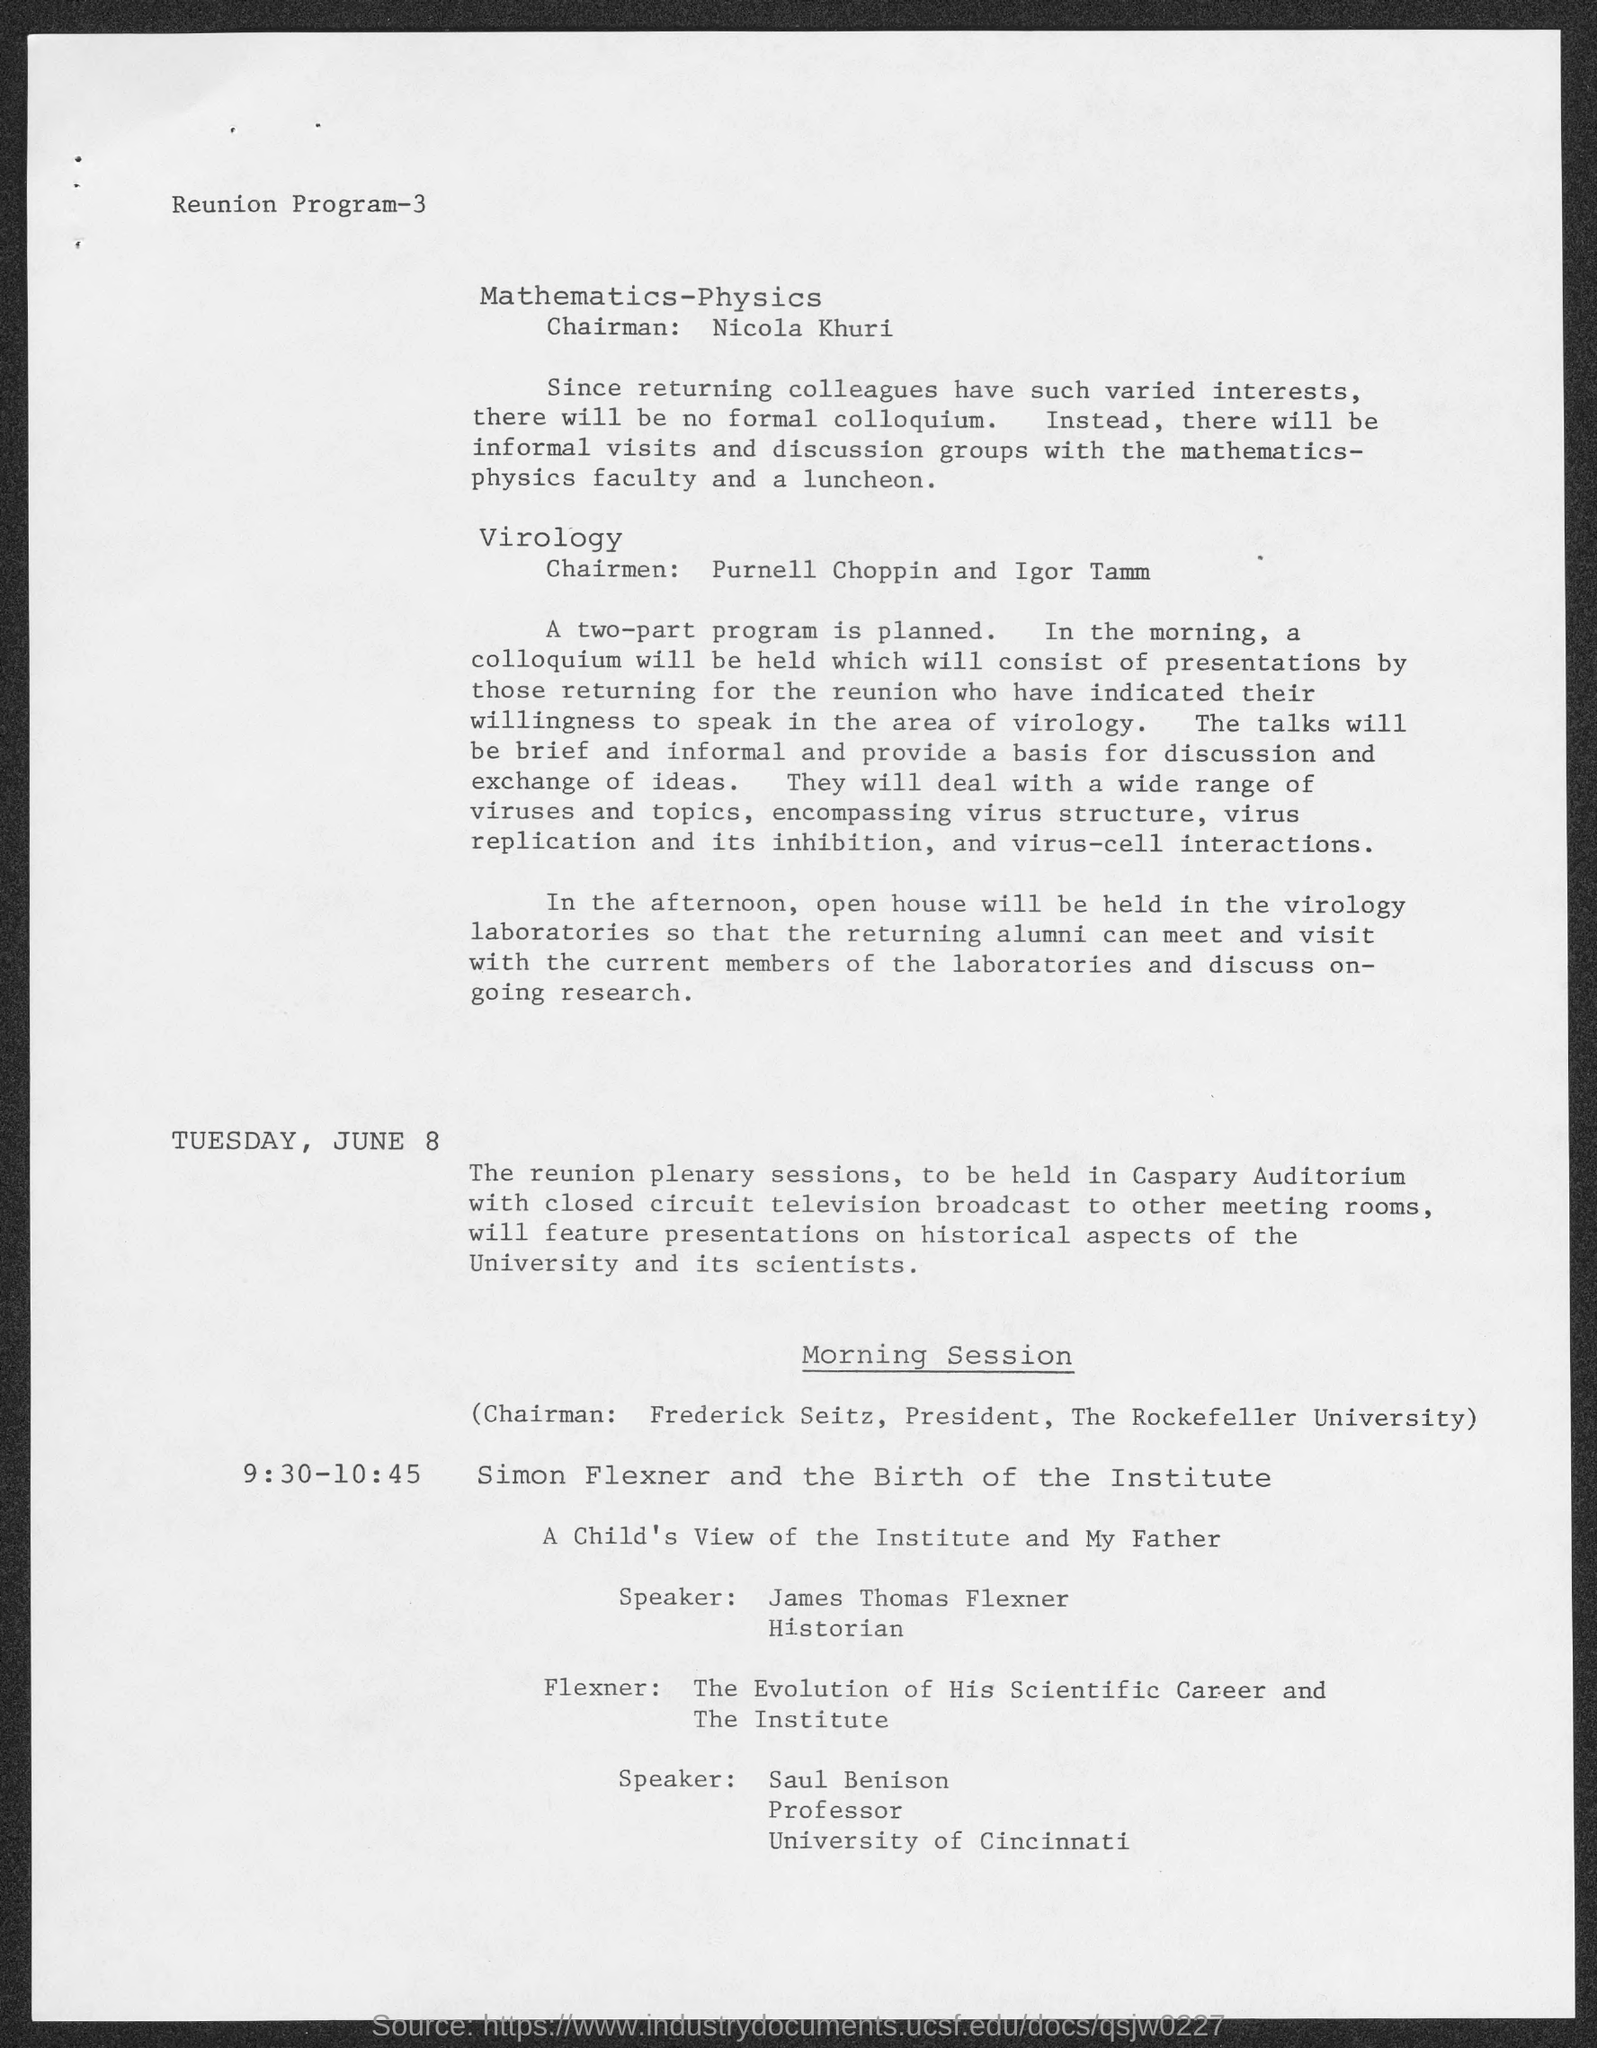Outline some significant characteristics in this image. James Thomas Flexner is the speaker for "A Child's View of the Institute" and "My Father. The person named Saul Benison belongs to the University of Cincinnati. Nicola Khuri is the chairman of Mathematics-Physics. At the morning session, Frederick Seitz is the chairman. Frederick Seitz is a member of Rockefeller University. 